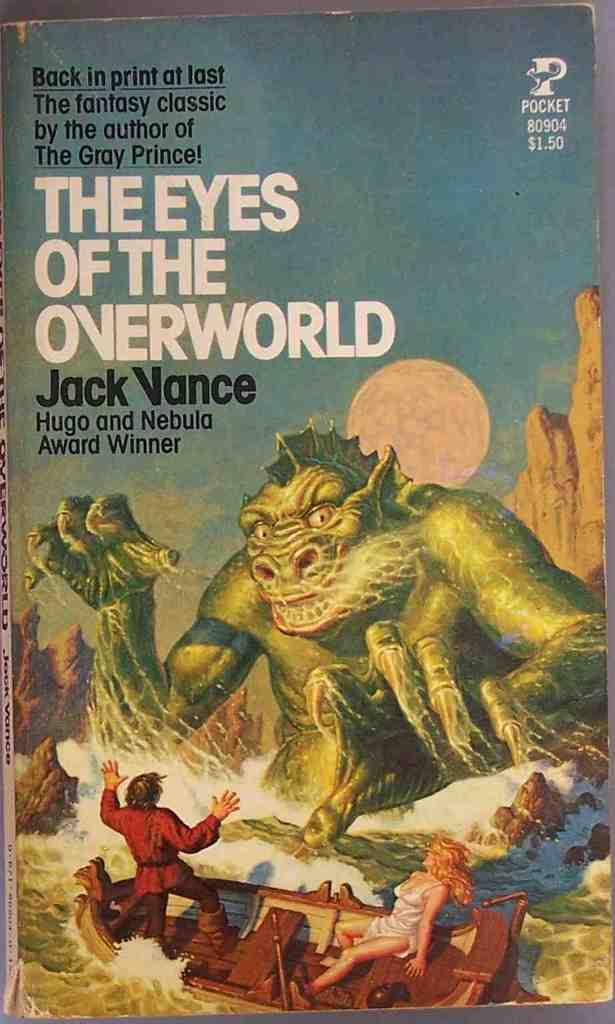Provide a one-sentence caption for the provided image. $1.50 pocket book the eyes of the overworld by jack vance. 